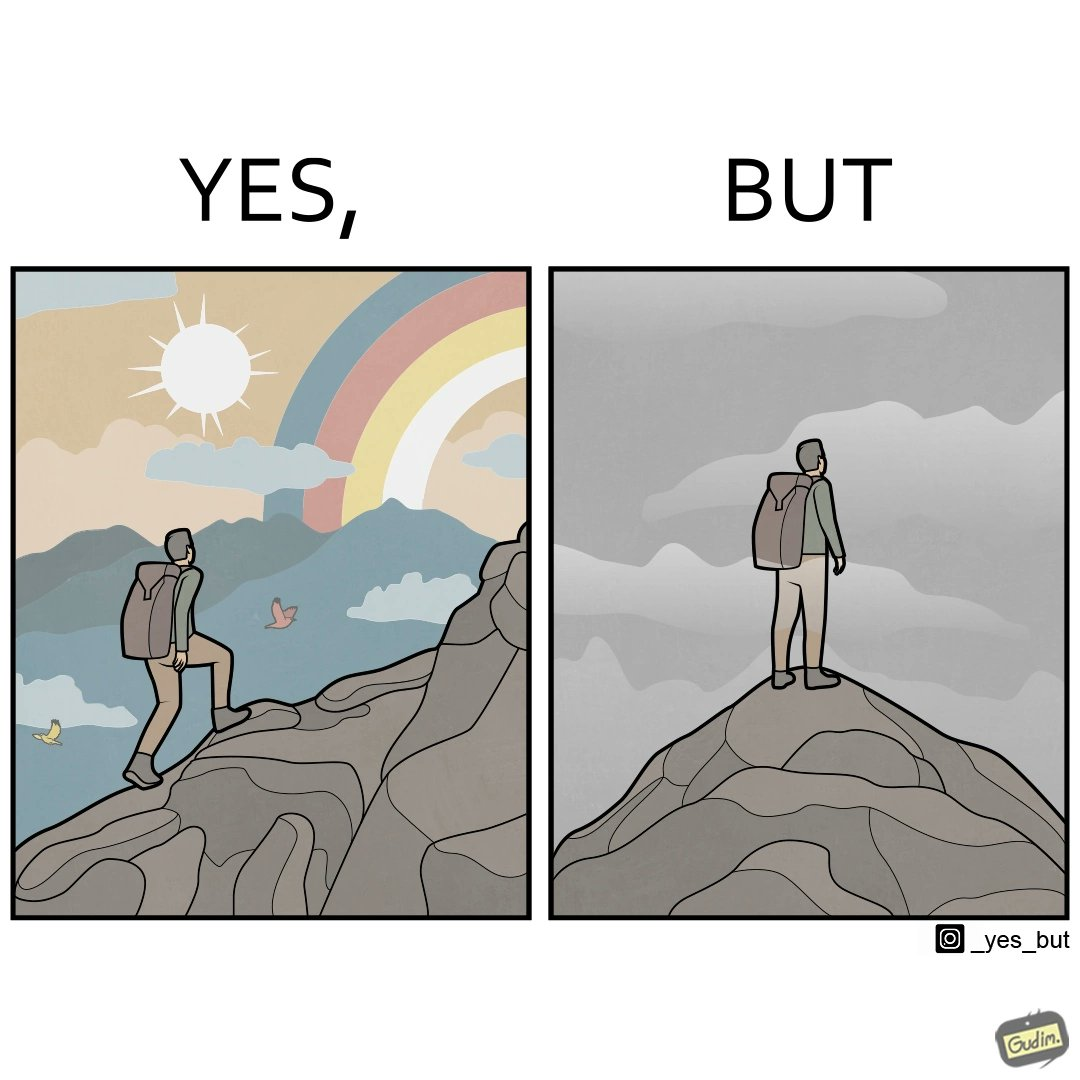Explain the humor or irony in this image. The image is ironic, because the mountaineer climbs up the mountain to view the world from the peak but due to so much cloud, at the top, nothing is visible whereas he was able to witness some awesome views while climbing up the mountain 